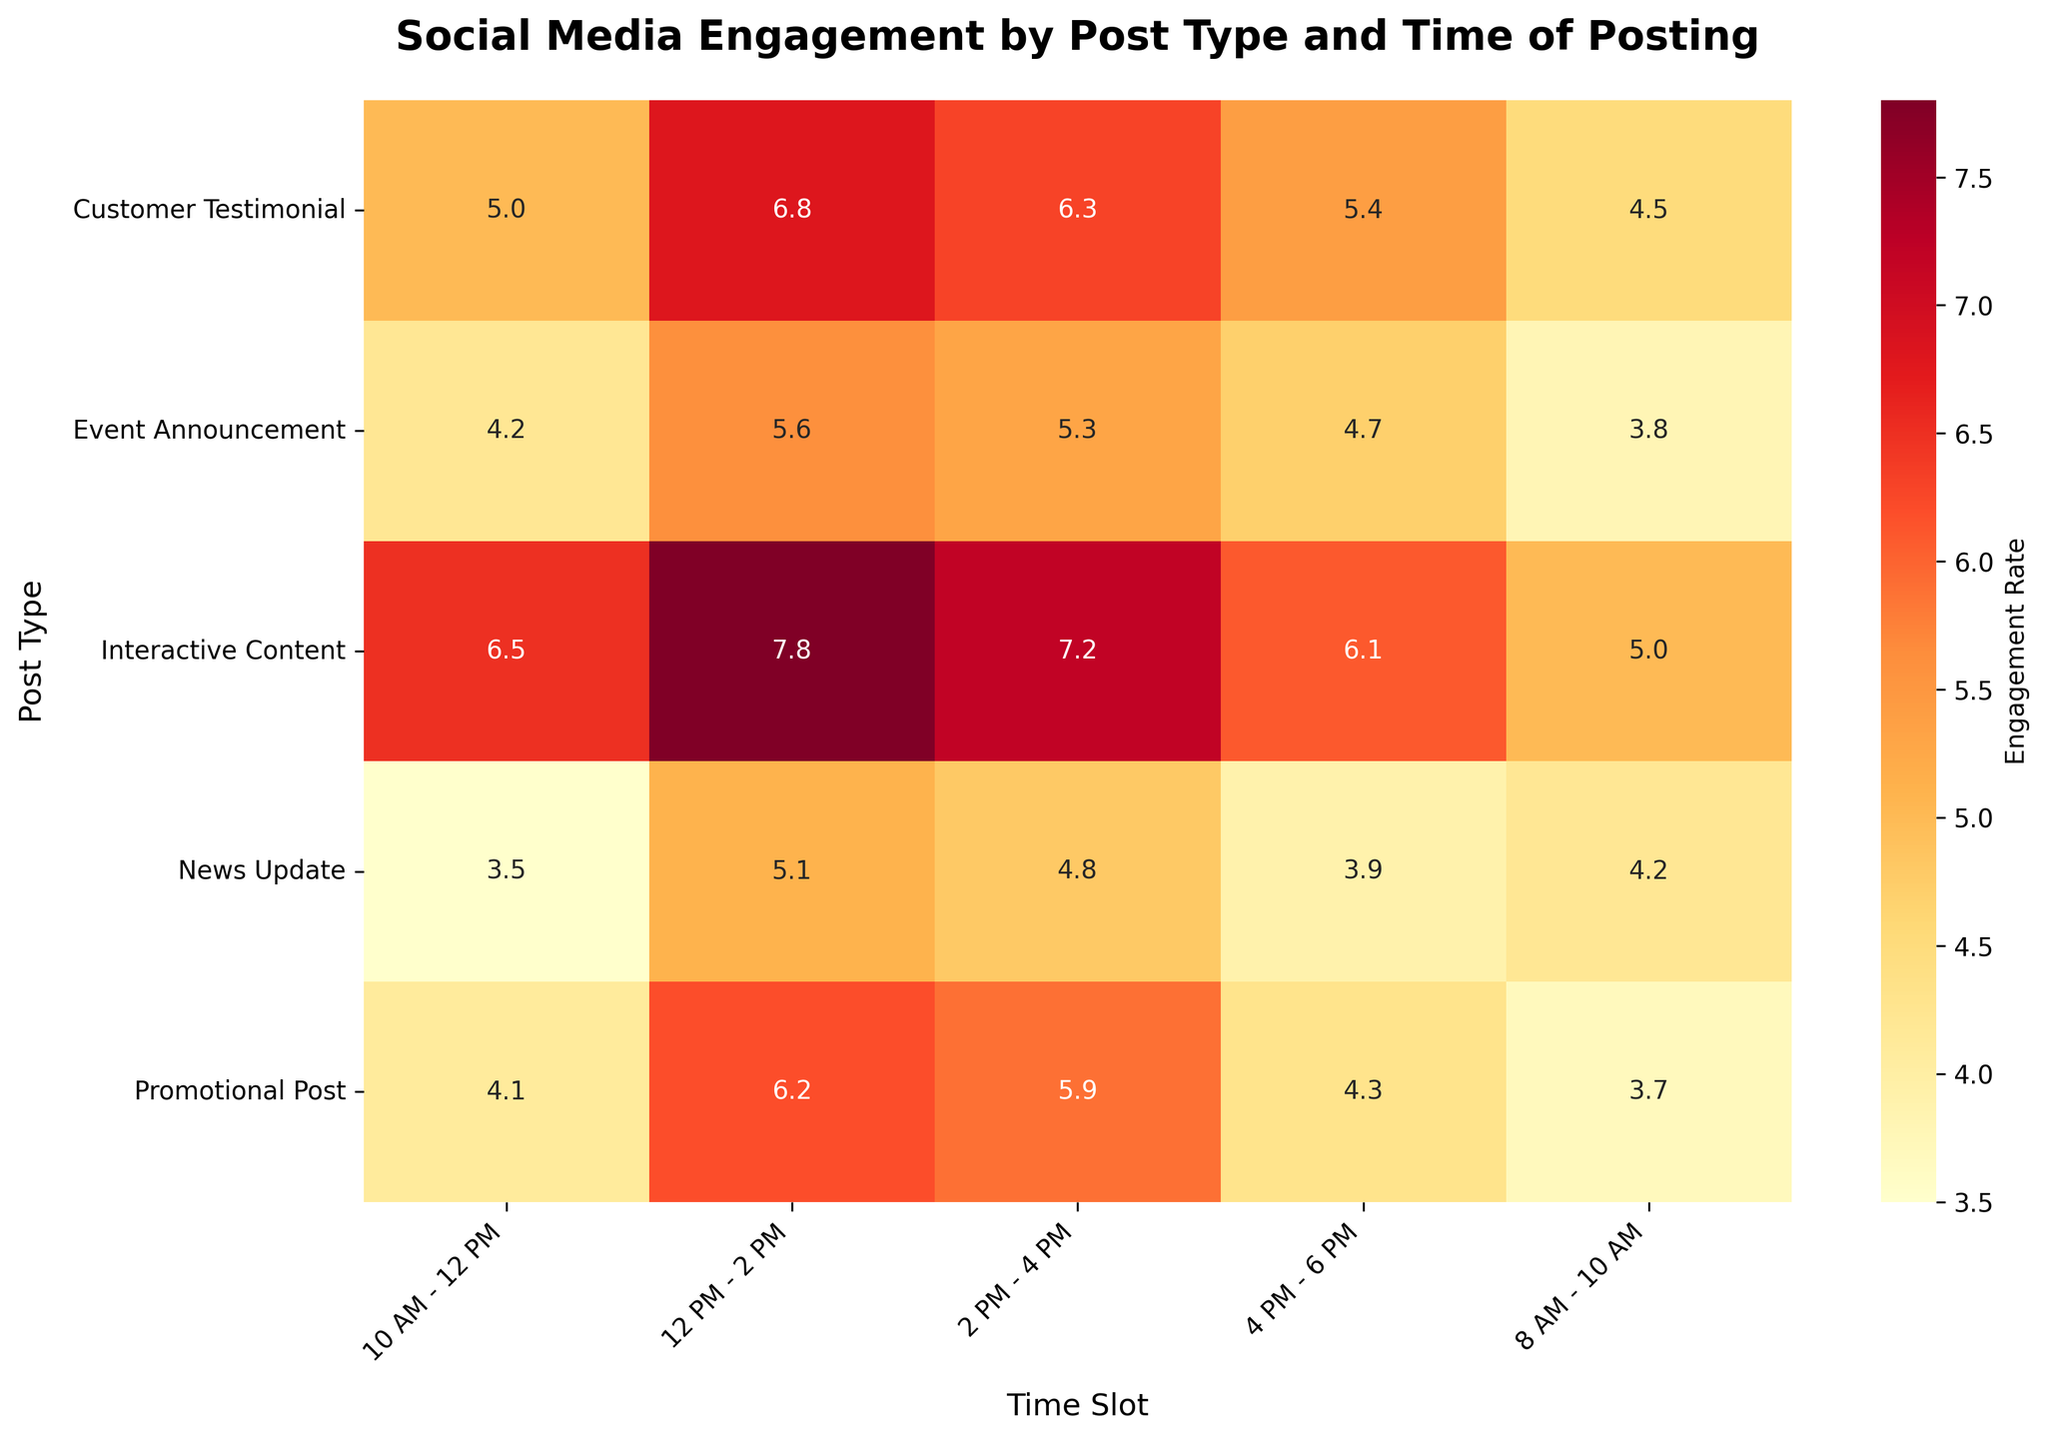What is the title of the heatmap? The title of the heatmap is found at the top of the figure, usually in a larger and bold font size. It provides the main context of the data visualization.
Answer: Social Media Engagement by Post Type and Time of Posting Which post type has the highest engagement rate in the time slot 12 PM - 2 PM? To find the answer, locate the 12 PM - 2 PM column and identify the highest value in that column. The highest engagement rate is found in the row corresponding to that value.
Answer: Interactive Content In which time slot does the "News Update" post type have the lowest engagement rate? Locate the row for "News Update" and identify the time slot with the smallest numerical value. This indicates the lowest engagement rate for that post type.
Answer: 10 AM - 12 PM What is the engagement rate of "Customer Testimonial" posts in the 2 PM - 4 PM time slot? Find the row labeled "Customer Testimonial" and then find the intersection with the column labeled "2 PM - 4 PM" to get the engagement rate value.
Answer: 6.3 Which post type and time slot combination has the overall lowest engagement rate? Scan the heatmap to find the smallest number and note its position in terms of post type and time slot.
Answer: News Update at 10 AM - 12 PM During which time slot do "Promotional Post" types experience the highest engagement rate? Locate the row for "Promotional Post" and identify the highest value in that row to find the corresponding time slot.
Answer: 12 PM - 2 PM How does the engagement rate of "Event Announcement" posts change from 8 AM - 10 AM to 4 PM - 6 PM? Track the engagement rates for "Event Announcement" posts across the relevant time slots and compare the values to detect changes.
Answer: It increases from 3.8 to 4.7 What is the difference in engagement rate between the highest and lowest performing time slots for "Interactive Content"? Identify the highest and lowest engagement rate values for "Interactive Content" and calculate the difference between them.
Answer: 7.8 - 5.0 = 2.8 What time slot generally seems to have the highest average engagement rate across all post types? Calculate the average engagement rate for each time slot by summing the engagement rates for all post types in each time slot and dividing by the number of post types. Then, compare the averages to identify the highest one.
Answer: 12 PM - 2 PM 